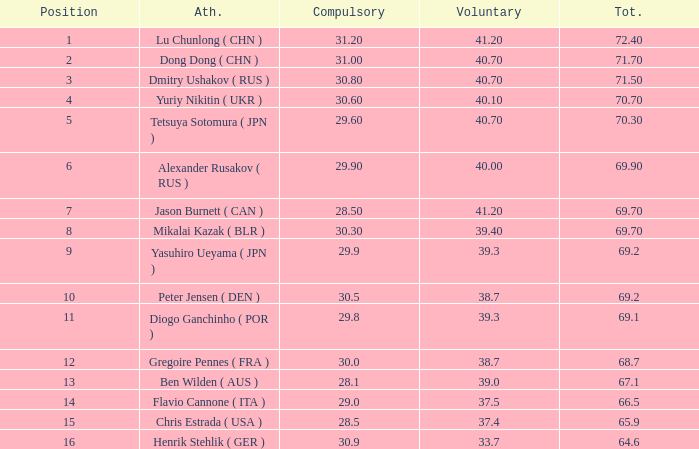What's the total of the position of 1? None. 